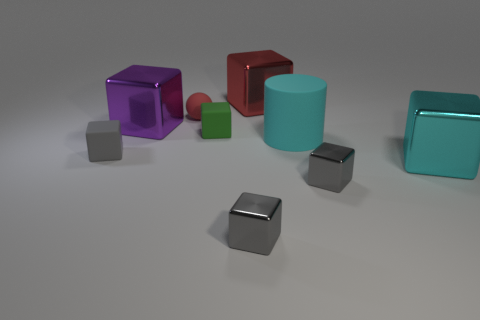Subtract all brown spheres. How many gray cubes are left? 3 Subtract 2 cubes. How many cubes are left? 5 Subtract all red blocks. How many blocks are left? 6 Subtract all big red metallic blocks. How many blocks are left? 6 Subtract all brown cubes. Subtract all yellow cylinders. How many cubes are left? 7 Subtract all spheres. How many objects are left? 8 Subtract 1 red balls. How many objects are left? 8 Subtract all small brown balls. Subtract all big cylinders. How many objects are left? 8 Add 2 large purple metal objects. How many large purple metal objects are left? 3 Add 2 big red things. How many big red things exist? 3 